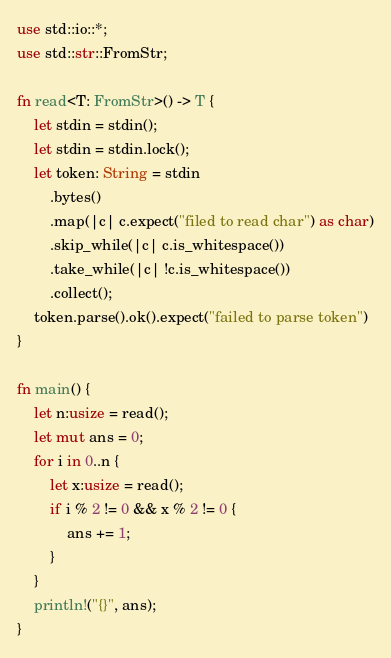<code> <loc_0><loc_0><loc_500><loc_500><_Rust_>use std::io::*;
use std::str::FromStr;

fn read<T: FromStr>() -> T {
    let stdin = stdin();
    let stdin = stdin.lock();
    let token: String = stdin
        .bytes()
        .map(|c| c.expect("filed to read char") as char)
        .skip_while(|c| c.is_whitespace())
        .take_while(|c| !c.is_whitespace())
        .collect();
    token.parse().ok().expect("failed to parse token")
}

fn main() {
    let n:usize = read();
    let mut ans = 0;
    for i in 0..n {
        let x:usize = read();
        if i % 2 != 0 && x % 2 != 0 {
            ans += 1;
        }
    }
    println!("{}", ans);
}
</code> 